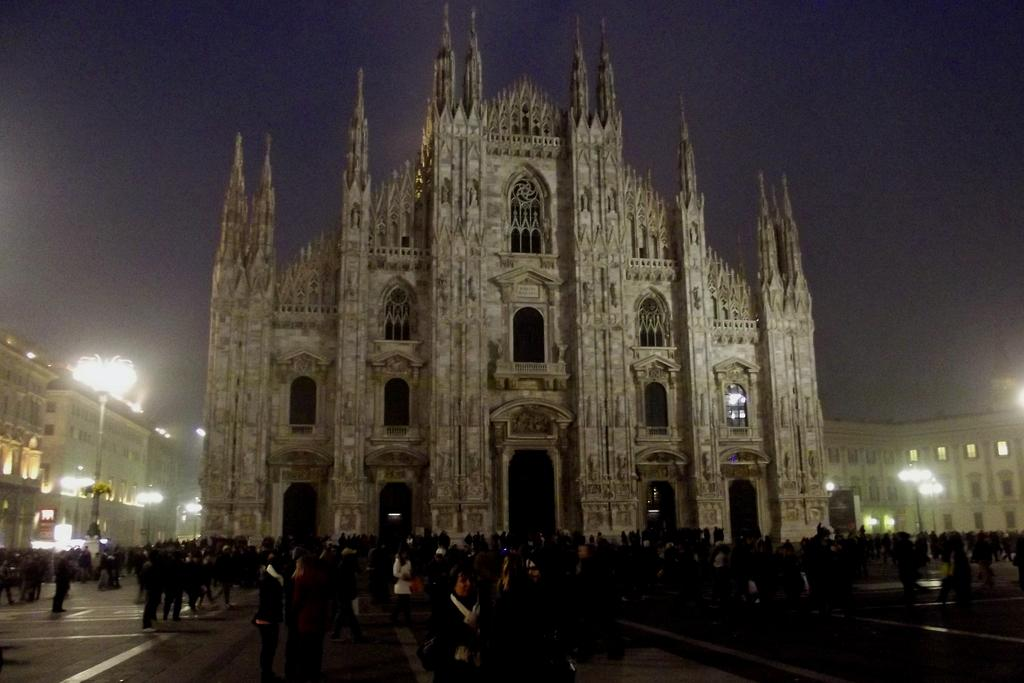What can be seen at the bottom of the image? There are people at the bottom of the image. What is the main structure in the middle of the image? There is a monument in the middle of the image. What is located on the left side of the image? There are lights on the left side of the image. What is visible at the top of the image? The sky is visible at the top of the image. Can you tell me how many chess pieces are on the monument in the image? There is no mention of chess pieces or a game of chess in the image; it features a monument and people. What type of vacation destination is depicted in the image? The image does not depict a vacation destination; it shows a monument, lights, and people. 